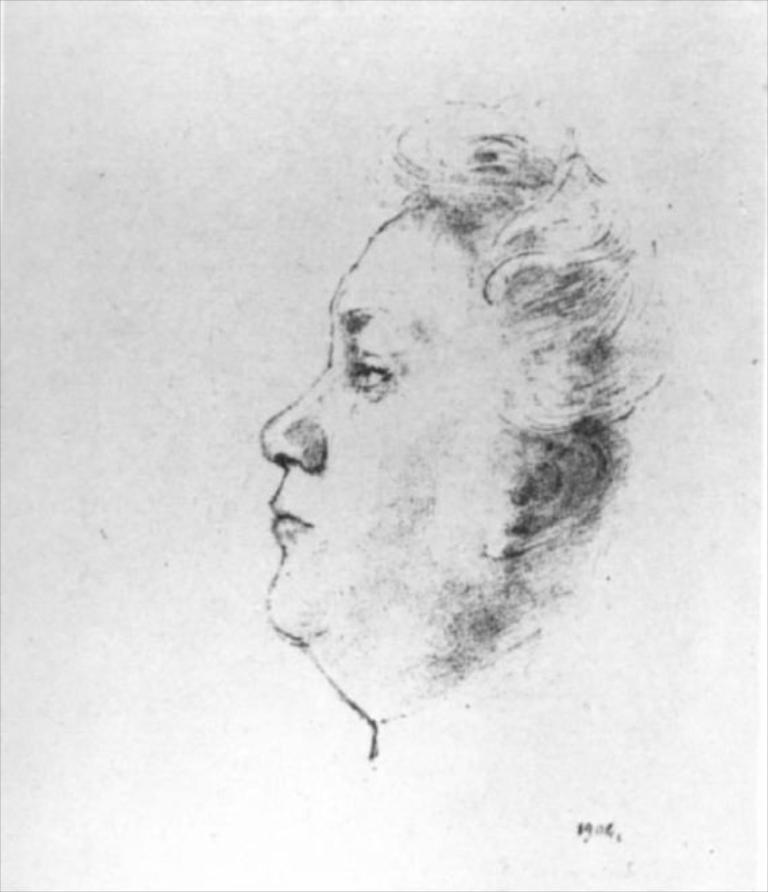What type of artwork is depicted in the image? There is a pencil sketch in the image. What subject is the sketch focused on? The sketch is of a person. What color is the gold necklace worn by the person in the sketch? There is no mention of a gold necklace or any jewelry in the image; the sketch is of a person, but no specific details about the person's appearance are provided. 